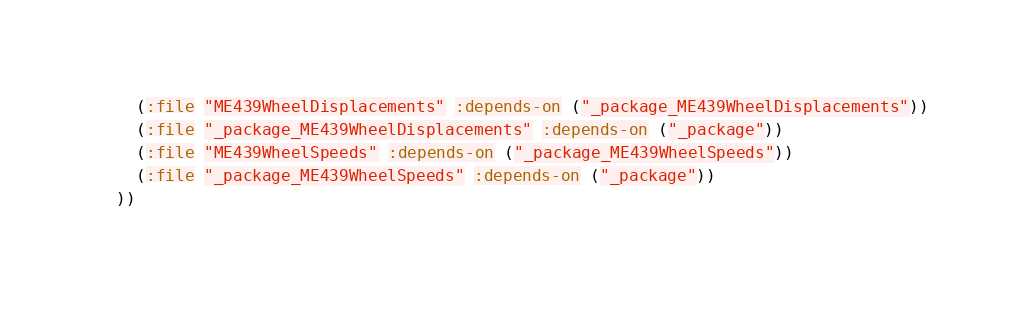<code> <loc_0><loc_0><loc_500><loc_500><_Lisp_>    (:file "ME439WheelDisplacements" :depends-on ("_package_ME439WheelDisplacements"))
    (:file "_package_ME439WheelDisplacements" :depends-on ("_package"))
    (:file "ME439WheelSpeeds" :depends-on ("_package_ME439WheelSpeeds"))
    (:file "_package_ME439WheelSpeeds" :depends-on ("_package"))
  ))</code> 